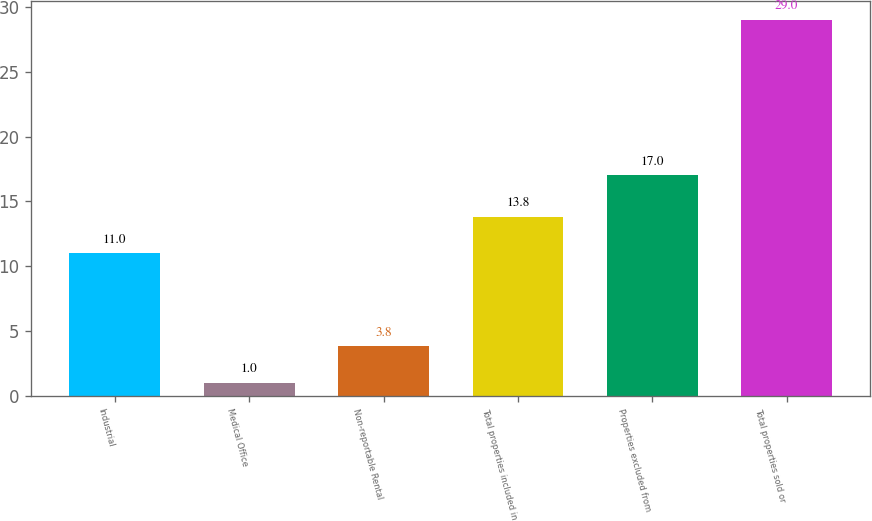<chart> <loc_0><loc_0><loc_500><loc_500><bar_chart><fcel>Industrial<fcel>Medical Office<fcel>Non-reportable Rental<fcel>Total properties included in<fcel>Properties excluded from<fcel>Total properties sold or<nl><fcel>11<fcel>1<fcel>3.8<fcel>13.8<fcel>17<fcel>29<nl></chart> 